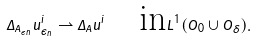Convert formula to latex. <formula><loc_0><loc_0><loc_500><loc_500>\Delta _ { A _ { \epsilon _ { n } } } u _ { \epsilon _ { n } } ^ { i } \rightharpoonup \Delta _ { A } u ^ { i } \quad \text {in} L ^ { 1 } ( O _ { 0 } \cup O _ { \delta } ) .</formula> 